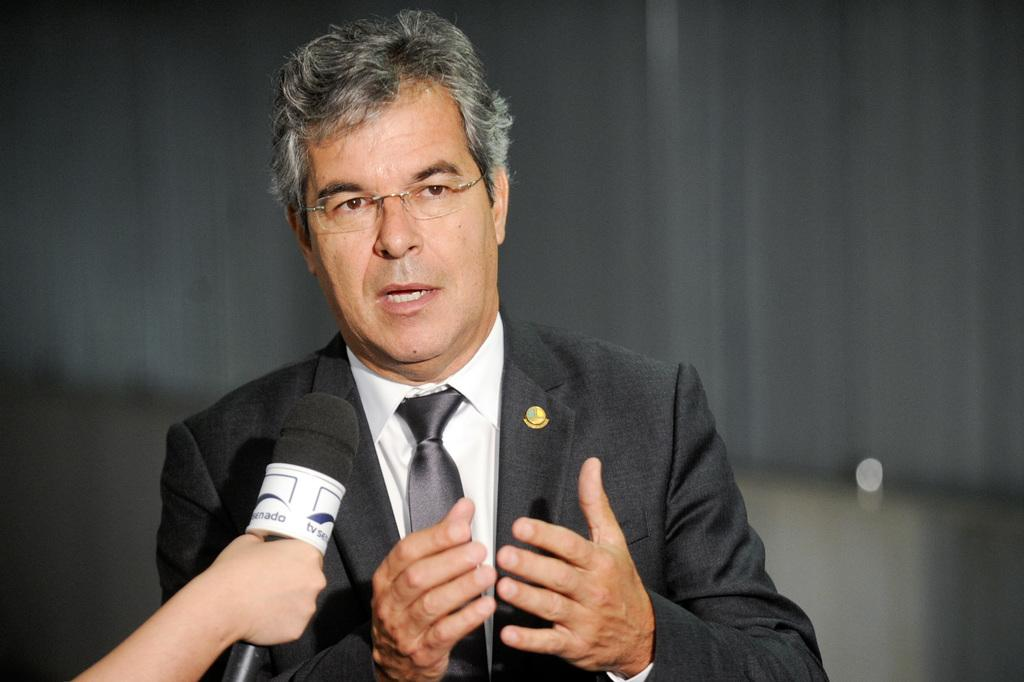What is the main subject of the image? There is a person in the image. What is the person doing in the image? The person is speaking into a microphone. Can you describe any other visible body parts of the person? A hand of a person is visible at the bottom of the image. Who is holding the microphone in the image? A person is holding the microphone. What is the aftermath of the person's stomach in the image? There is no mention of the person's stomach in the image, so it is not possible to determine the aftermath. 